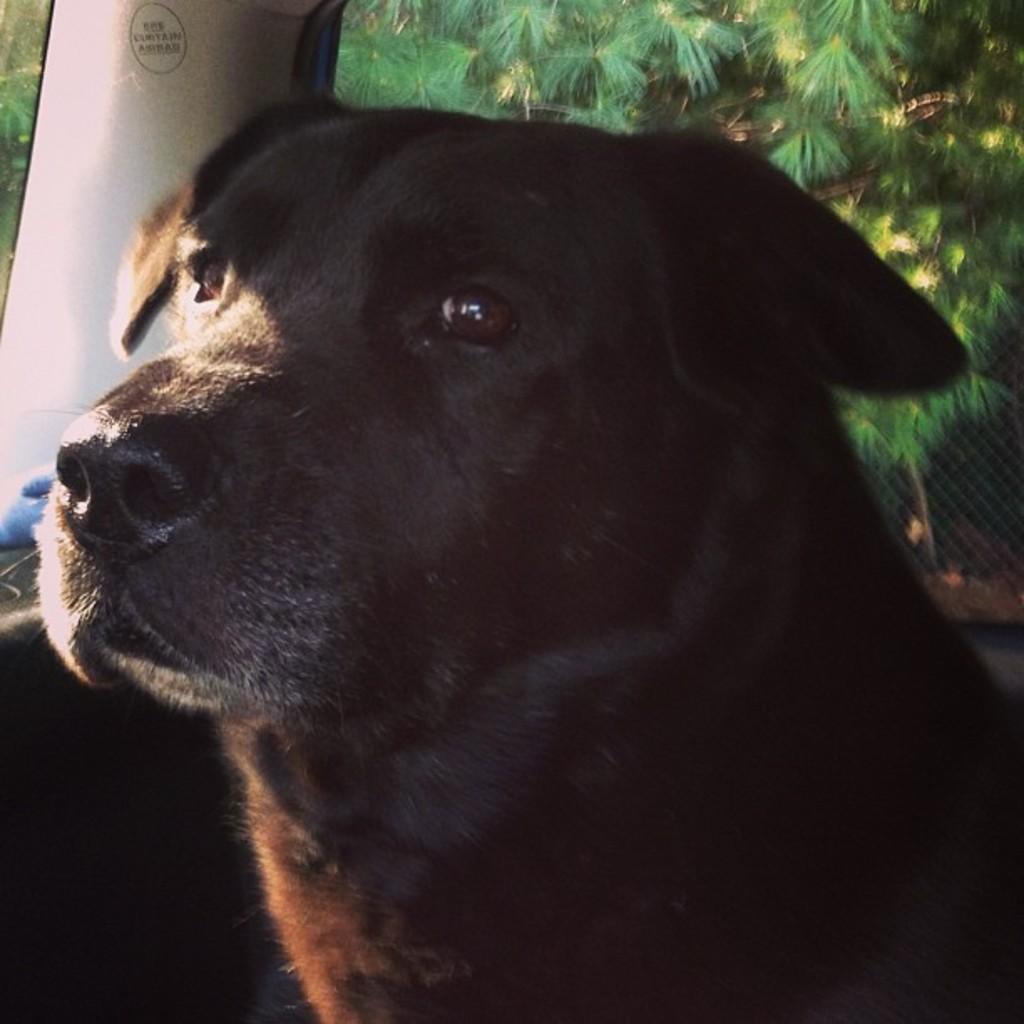Could you give a brief overview of what you see in this image? In this image in the foreground there is one dog, and it seems that the dog is in vehicle. And in the background there are some plants and net. 